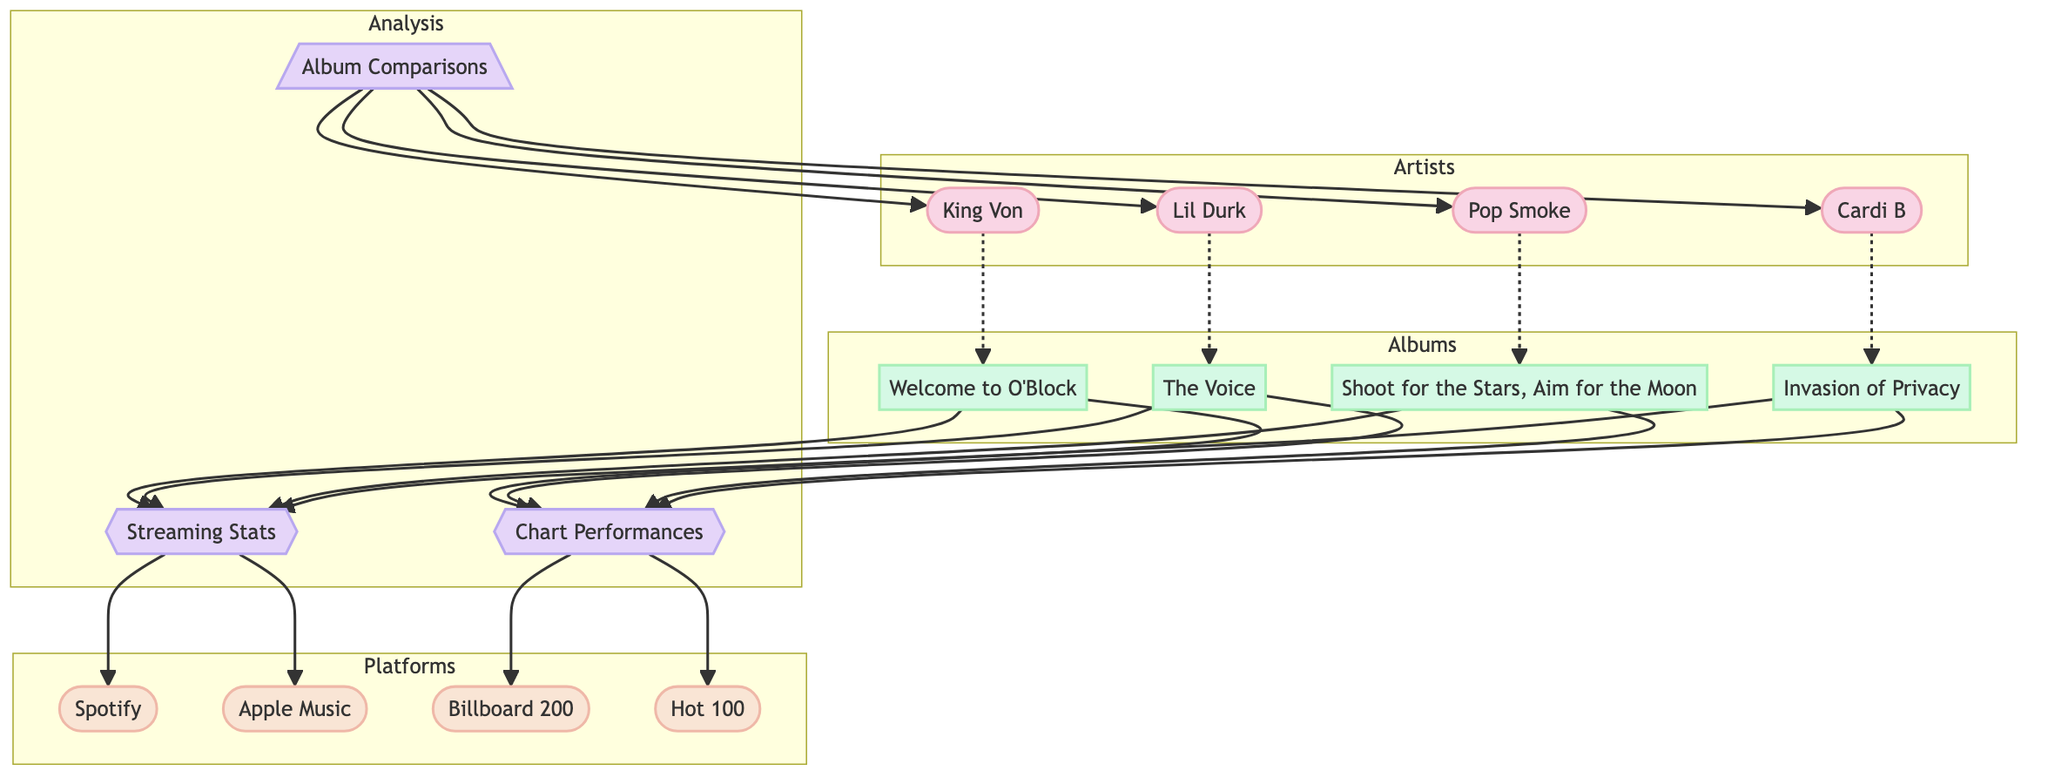What albums are associated with King Von? The diagram shows that King Von is connected to the album "Welcome to O'Block." This can be identified by following the edge between the artist node for King Von and the album node for "Welcome to O'Block."
Answer: Welcome to O'Block How many artists are represented in this diagram? By counting the artist nodes, we find King Von, Lil Durk, Pop Smoke, and Cardi B, which totals to four distinct artist nodes in the diagram.
Answer: 4 Which platform has a connection to Chart Performances? The diagram indicates that the connections leading to Chart Performances come from the album nodes. The chart performance nodes indicate both Billboard 200 and Hot 100, which are more like categorizations rather than platforms. From the diagram, there is no direct platform connection indicated for Chart Performances based on the question's context; thus, we examine the closest relevant aspect, which are the Billboard 200 and Hot 100.
Answer: Billboard 200 and Hot 100 What relationship exists between Streaming Stats and the artists? The Streaming Stats node connects to the Spotify and Apple Music nodes, while the artists are connected to their respective albums — these album nodes lead to the Streaming Stats. This indicates that the streaming statistics are derived from the artists through their album releases. Therefore, each artist influences their streaming stats indirectly through their albums.
Answer: Indirect connection through albums Which artist's album connects directly to both streaming platforms? From the diagram, we check the relationships established, where the albums are the potential connections to the streaming platforms. Each album of the artists flows to Streaming Stats, making them all indirectly connected. However, every album ultimately leads to the connection with both Spotify and Apple Music indicating that they all have streaming connections.
Answer: All artists' albums 